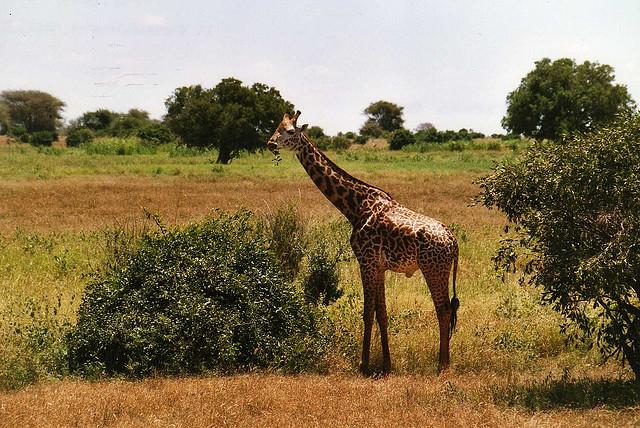Is this giraffe male or female?
Keep it brief. Male. Are there signs of dehydration in this scene?
Answer briefly. Yes. Is this giraffe afraid of people?
Keep it brief. No. 